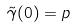<formula> <loc_0><loc_0><loc_500><loc_500>\tilde { \gamma } ( 0 ) = p</formula> 